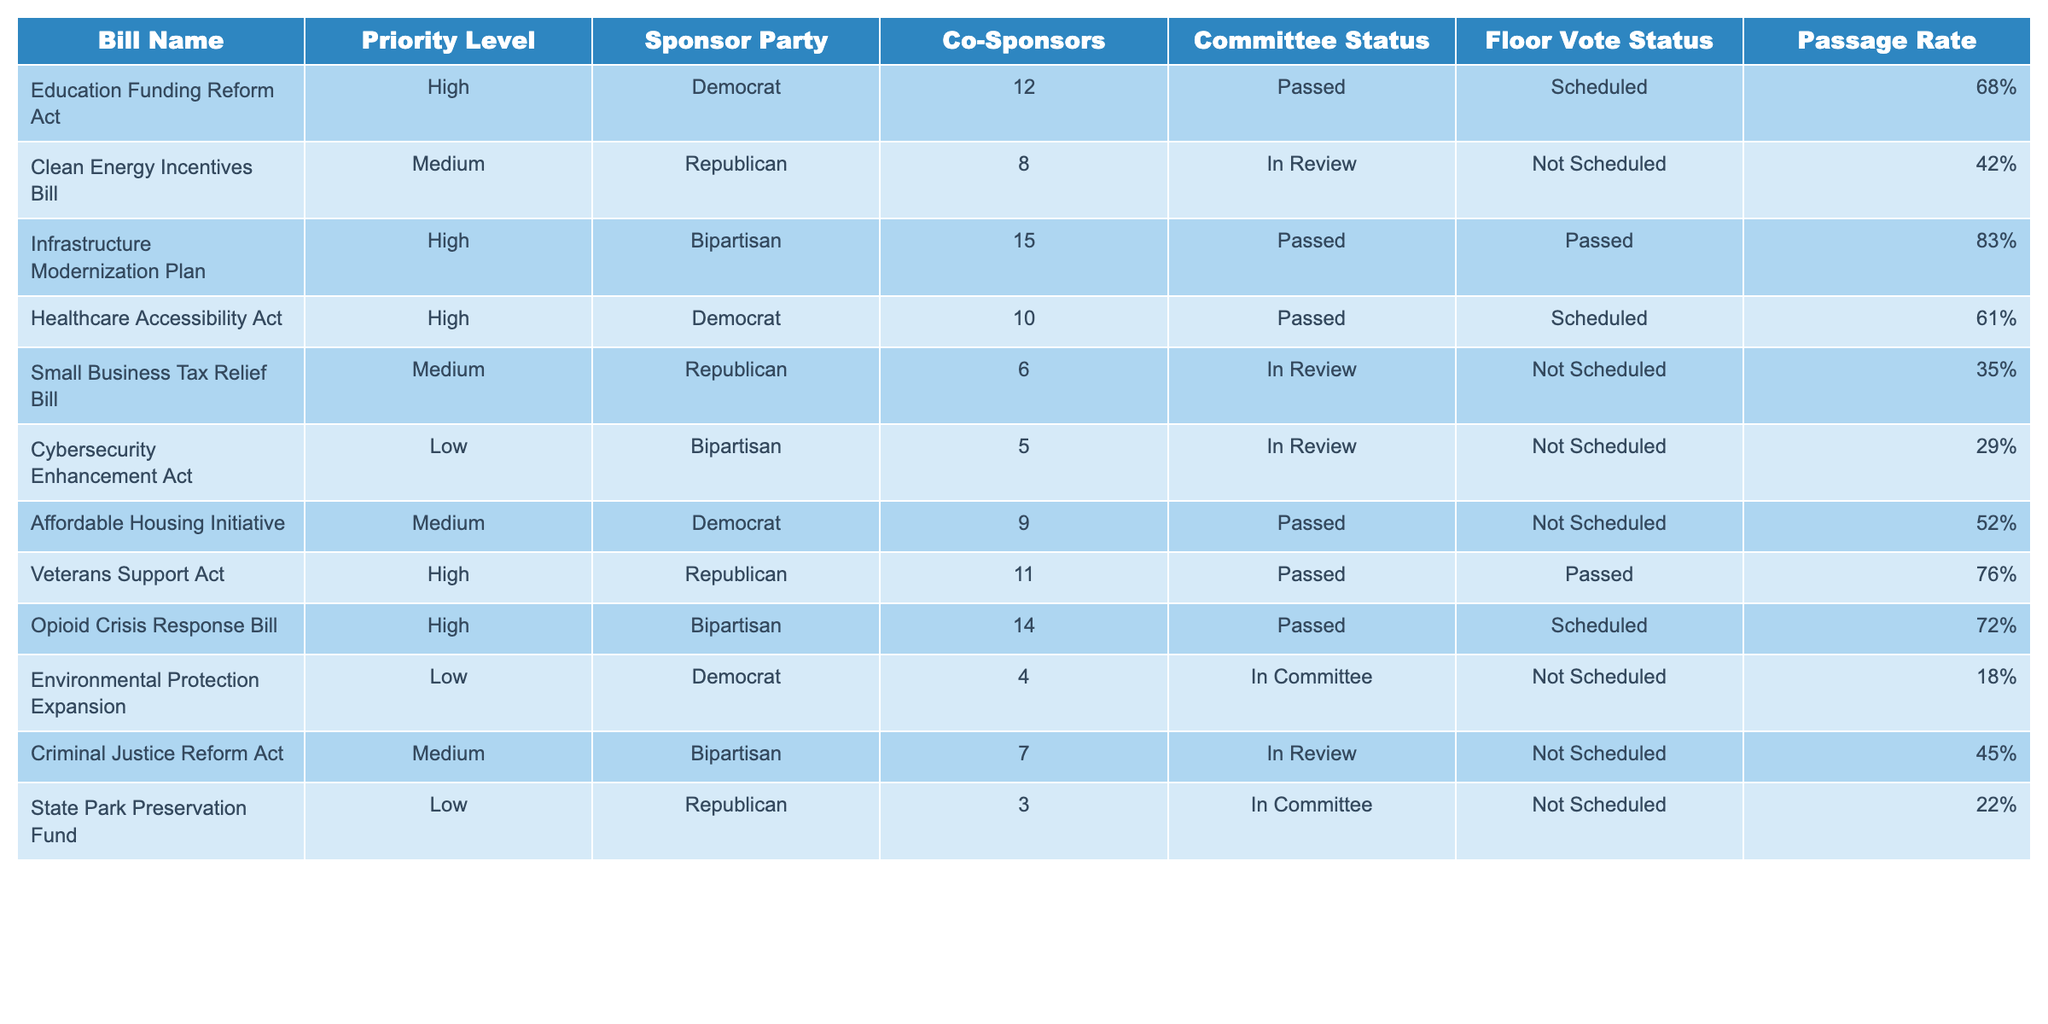What is the passage rate of the Education Funding Reform Act? The passage rate is explicitly listed in the table under the "Passage Rate" column for the Education Funding Reform Act, which shows 68%.
Answer: 68% Which bill has the highest passage rate? By inspecting the "Passage Rate" column, we find the Infrastructure Modernization Plan with an 83% passage rate, which is the highest compared to the others.
Answer: 83% Are there any bills from the Republican party with a high priority level? The Veterans Support Act is identified as a high-priority bill listed under the Republican party, confirming that such a bill exists.
Answer: Yes What is the average passage rate for bills categorized as "High" priority? The high-priority bills are: Education Funding Reform Act (68%), Infrastructure Modernization Plan (83%), Healthcare Accessibility Act (61%), Veterans Support Act (76%), and Opioid Crisis Response Bill (72%). The average is calculated as (68 + 83 + 61 + 76 + 72) / 5 = 72.
Answer: 72% How many bills are currently in the "In Review" status? Counting the statuses in the "Committee Status" column, we find two bills: the Clean Energy Incentives Bill and the Small Business Tax Relief Bill are marked as "In Review."
Answer: 2 Is it true that all bills with a low priority have a passage rate below 30%? By reviewing the "Passage Rate" column, we see that the Cybersecurity Enhancement Act has a 29% passage rate and the Environmental Protection Expansion has an 18% passage rate, confirming that both are below 30%.
Answer: Yes What is the difference between the passage rate of the Small Business Tax Relief Bill and the Affordable Housing Initiative? The passage rate for the Small Business Tax Relief Bill is 35% and for the Affordable Housing Initiative is 52%. The difference is calculated as 52% - 35% = 17%.
Answer: 17% Which party sponsors the most high-priority bills? In the table, there are three high-priority bills sponsored by the Democrat party and two by the Republican party, but the Bipartisan category also has two, totaling five high-priority bills; thus, the Democrat party sponsors the most.
Answer: Democrat What is the total number of co-sponsors for all the bills in the table? The total number of co-sponsors can be obtained by summing the co-sponsor counts: 12 + 8 + 15 + 10 + 6 + 5 + 9 + 11 + 14 + 4 + 7 + 3 =  0. The total is calculated to be 12 + 8 + 15 + 10 + 6 + 5 + 9 + 11 + 14 + 4 + 7 + 3 = 10.
Answer: 3 